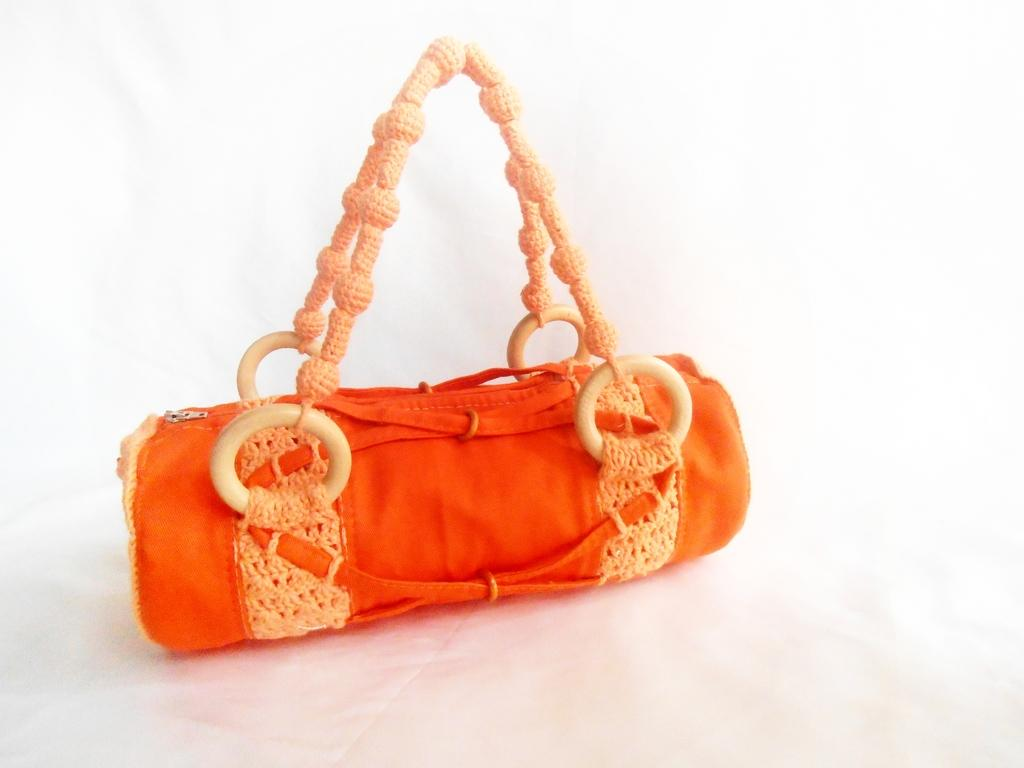What object is present in the image? There is a handbag in the image. What is the color of the handbag? The handbag is orange in color. How is the handbag being held or carried? The handbag holder is in a light color, indicating that someone is holding or carrying the handbag. What additional detail can be observed about the handbag holder? The handbag holder has some plastic rings. How many spiders are crawling on the handbag in the image? There are no spiders present in the image; it only features a handbag and its holder. What type of cap is the person wearing in the image? There is no person or cap visible in the image; it only shows a handbag and its holder. 